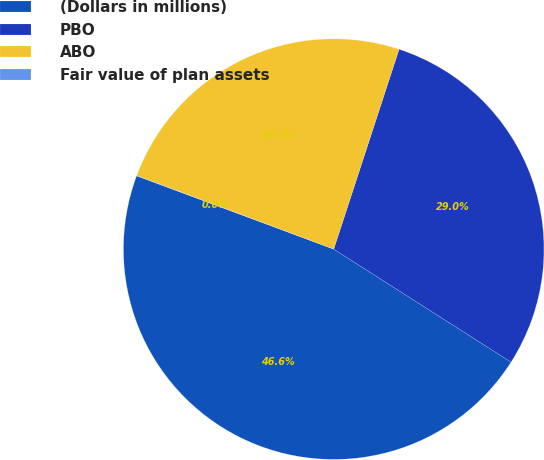Convert chart. <chart><loc_0><loc_0><loc_500><loc_500><pie_chart><fcel>(Dollars in millions)<fcel>PBO<fcel>ABO<fcel>Fair value of plan assets<nl><fcel>46.63%<fcel>29.0%<fcel>24.34%<fcel>0.02%<nl></chart> 